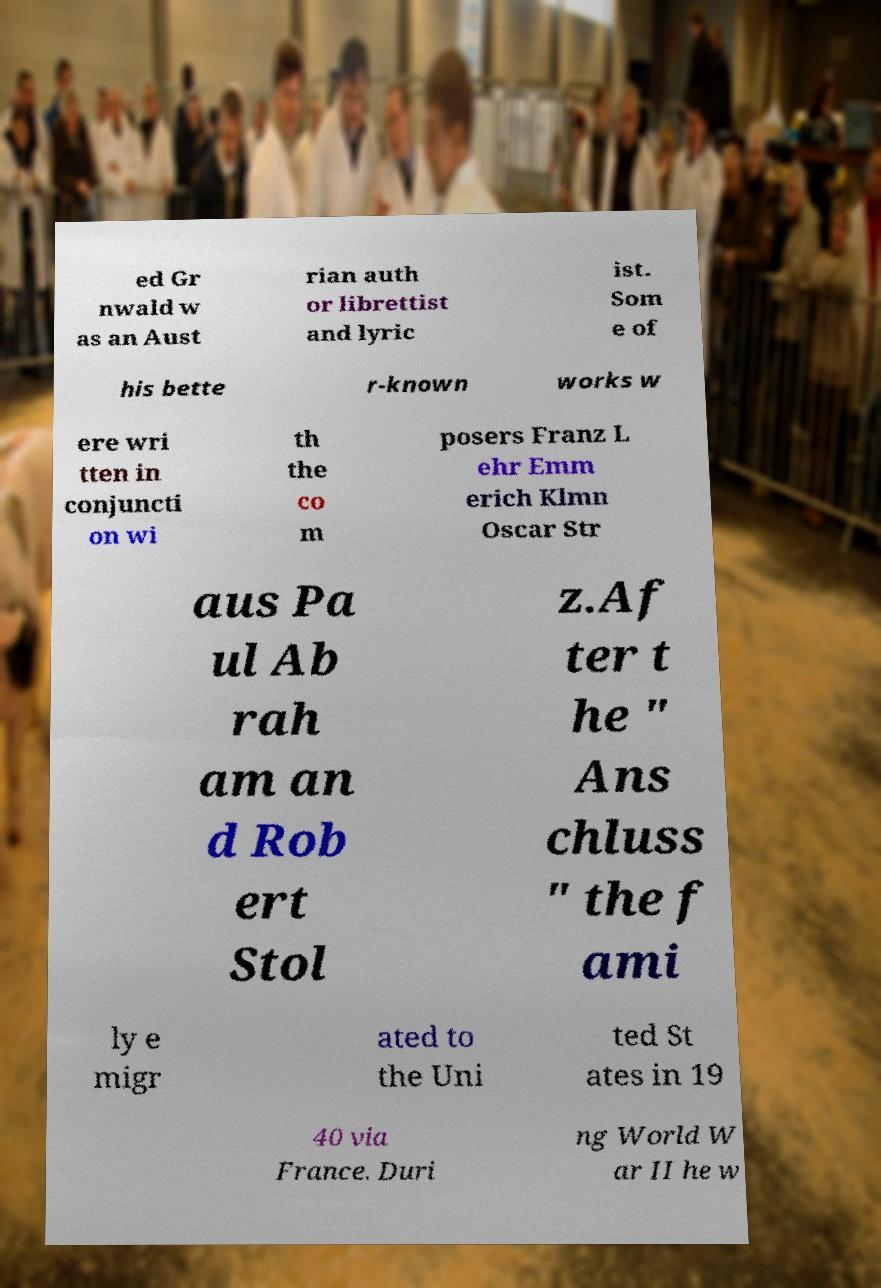For documentation purposes, I need the text within this image transcribed. Could you provide that? ed Gr nwald w as an Aust rian auth or librettist and lyric ist. Som e of his bette r-known works w ere wri tten in conjuncti on wi th the co m posers Franz L ehr Emm erich Klmn Oscar Str aus Pa ul Ab rah am an d Rob ert Stol z.Af ter t he " Ans chluss " the f ami ly e migr ated to the Uni ted St ates in 19 40 via France. Duri ng World W ar II he w 